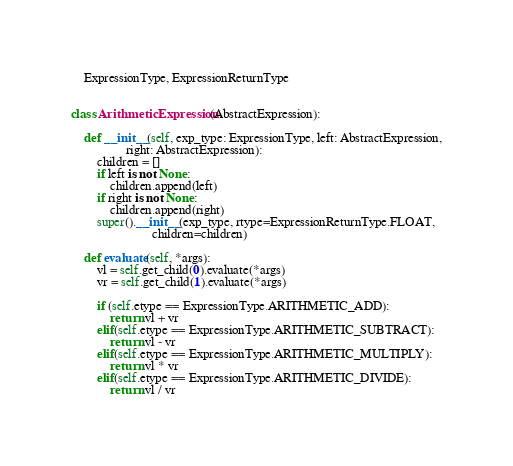<code> <loc_0><loc_0><loc_500><loc_500><_Python_>    ExpressionType, ExpressionReturnType


class ArithmeticExpression(AbstractExpression):

    def __init__(self, exp_type: ExpressionType, left: AbstractExpression,
                 right: AbstractExpression):
        children = []
        if left is not None:
            children.append(left)
        if right is not None:
            children.append(right)
        super().__init__(exp_type, rtype=ExpressionReturnType.FLOAT,
                         children=children)

    def evaluate(self, *args):
        vl = self.get_child(0).evaluate(*args)
        vr = self.get_child(1).evaluate(*args)

        if (self.etype == ExpressionType.ARITHMETIC_ADD):
            return vl + vr
        elif(self.etype == ExpressionType.ARITHMETIC_SUBTRACT):
            return vl - vr
        elif(self.etype == ExpressionType.ARITHMETIC_MULTIPLY):
            return vl * vr
        elif(self.etype == ExpressionType.ARITHMETIC_DIVIDE):
            return vl / vr
</code> 